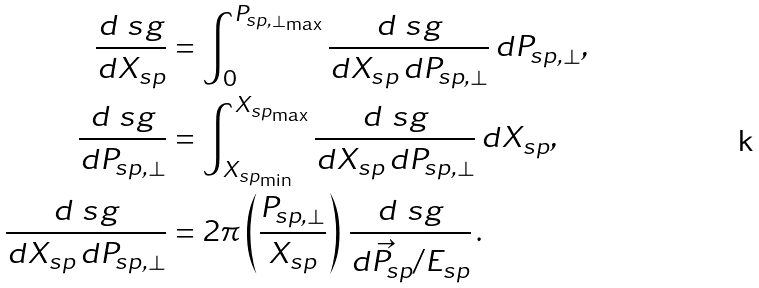<formula> <loc_0><loc_0><loc_500><loc_500>\frac { d \ s g } { d X _ { s p } } & = \int _ { 0 } ^ { P _ { s p , \bot _ { \max } } } \frac { d \ s g } { d X _ { s p } \, d P _ { s p , \bot } } \, d P _ { s p , \bot } , \\ \frac { d \ s g } { d P _ { s p , \bot } } & = \int _ { X _ { s p _ { \min } } } ^ { X _ { s p _ { \max } } } \frac { d \ s g } { d X _ { s p } \, d P _ { s p , \bot } } \, d X _ { s p } , \\ \frac { d \ s g } { d X _ { s p } \, d P _ { s p , \bot } } & = 2 \pi \left ( \frac { P _ { s p , \bot } } { X _ { s p } } \right ) \, \frac { d \ s g } { d \vec { P } _ { s p } / E _ { s p } } \, .</formula> 